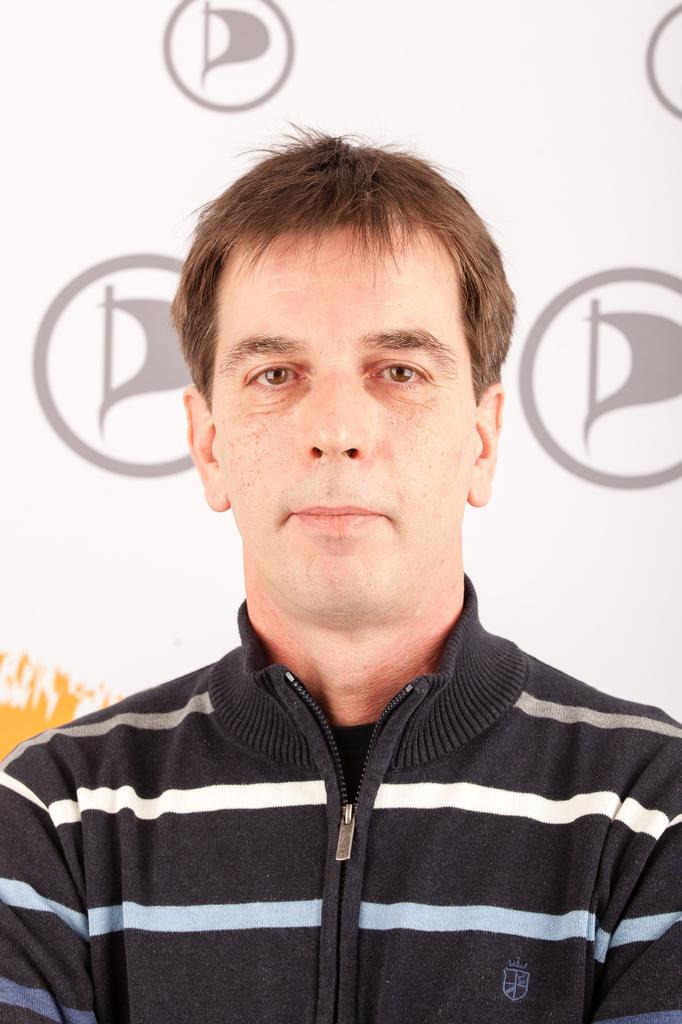Could you give a brief overview of what you see in this image? In this picture I can see a man in front and I see that he is wearing a jacket, which is of white, black, blue and grey color. In the background I can see a board on which there are few logos. 